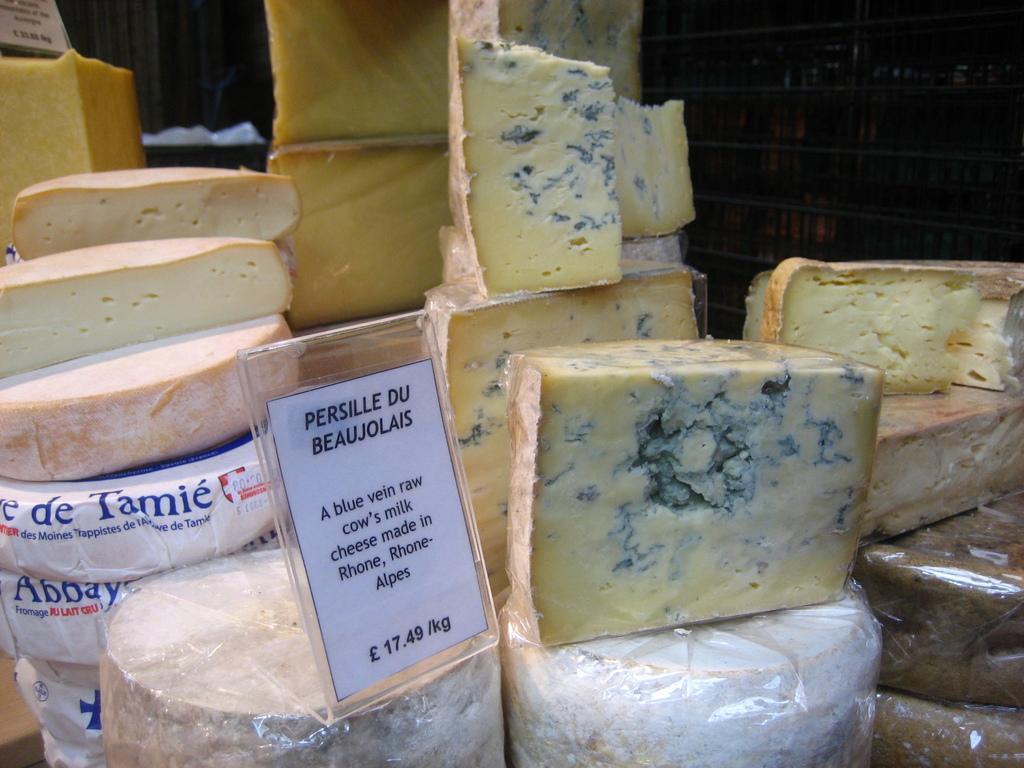Please provide a concise description of this image. In this image I can see the cheese which is in cream color. In-front of the cheese I can see the board and something is written on it. In the background I can see the black color surface. 